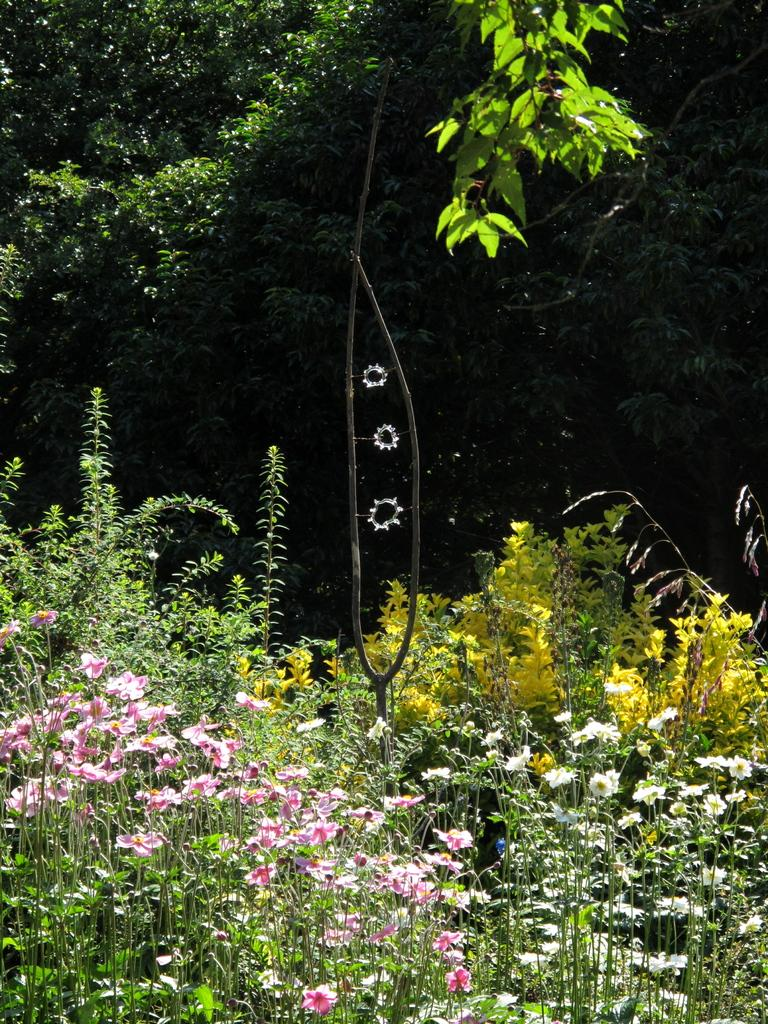What is located in the center of the image? There are trees in the center of the image. What can be found at the bottom of the image? There are plants at the bottom of the image. What type of flora is present in the image? There are flowers in the image. Can you tell me how many potatoes are hidden among the flowers in the image? There are no potatoes present in the image; it features trees, plants, and flowers. What type of kitty can be seen interacting with the flowers in the image? There is no kitty present in the image; only trees, plants, and flowers are depicted. 